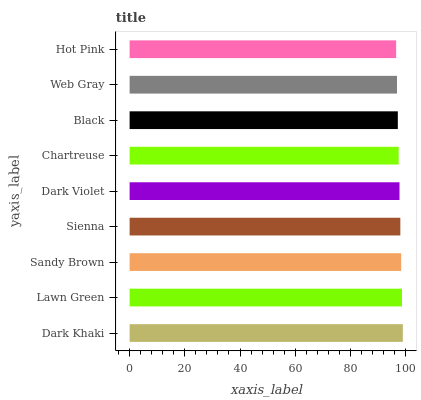Is Hot Pink the minimum?
Answer yes or no. Yes. Is Dark Khaki the maximum?
Answer yes or no. Yes. Is Lawn Green the minimum?
Answer yes or no. No. Is Lawn Green the maximum?
Answer yes or no. No. Is Dark Khaki greater than Lawn Green?
Answer yes or no. Yes. Is Lawn Green less than Dark Khaki?
Answer yes or no. Yes. Is Lawn Green greater than Dark Khaki?
Answer yes or no. No. Is Dark Khaki less than Lawn Green?
Answer yes or no. No. Is Dark Violet the high median?
Answer yes or no. Yes. Is Dark Violet the low median?
Answer yes or no. Yes. Is Black the high median?
Answer yes or no. No. Is Dark Khaki the low median?
Answer yes or no. No. 